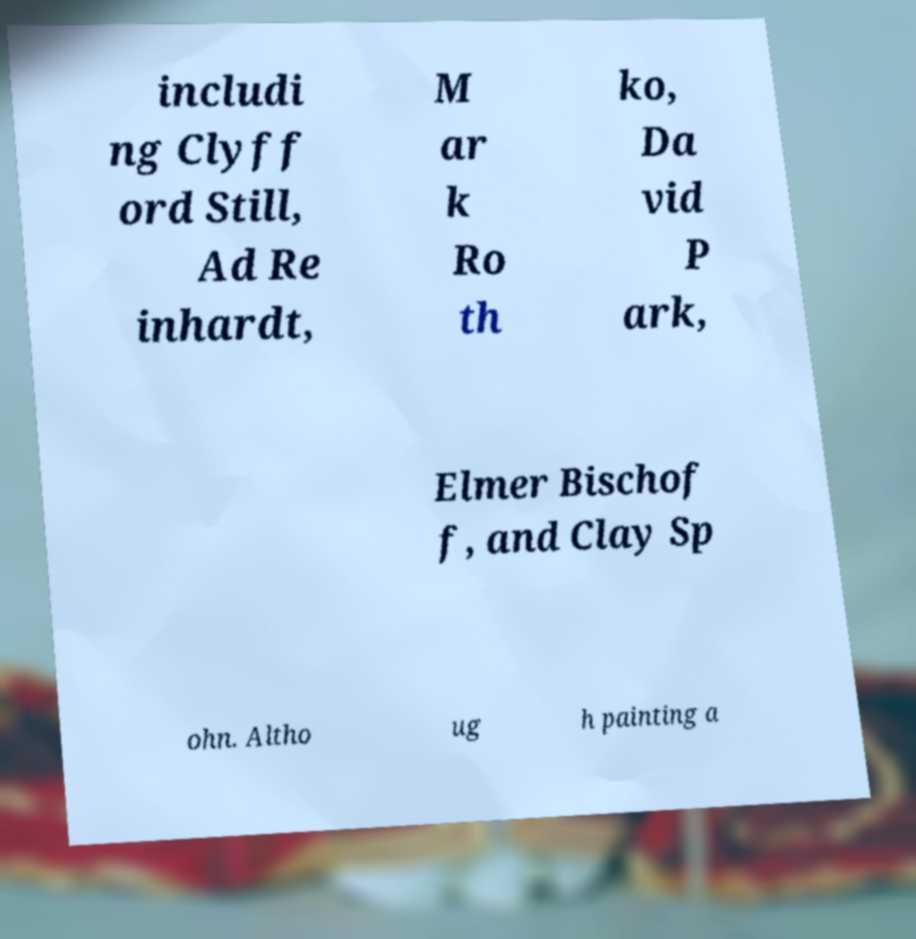I need the written content from this picture converted into text. Can you do that? includi ng Clyff ord Still, Ad Re inhardt, M ar k Ro th ko, Da vid P ark, Elmer Bischof f, and Clay Sp ohn. Altho ug h painting a 